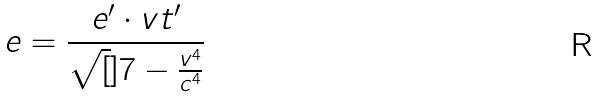<formula> <loc_0><loc_0><loc_500><loc_500>e = \frac { e ^ { \prime } \cdot v t ^ { \prime } } { \sqrt { [ } ] { 7 - \frac { v ^ { 4 } } { c ^ { 4 } } } }</formula> 